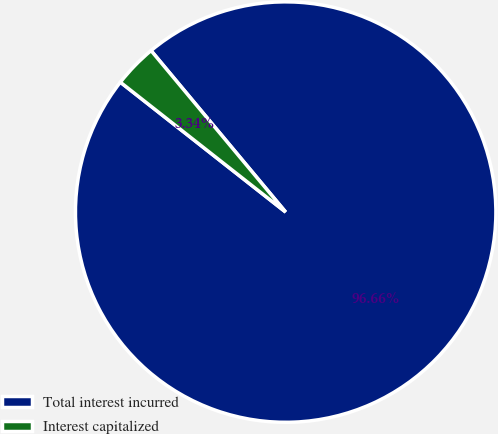<chart> <loc_0><loc_0><loc_500><loc_500><pie_chart><fcel>Total interest incurred<fcel>Interest capitalized<nl><fcel>96.66%<fcel>3.34%<nl></chart> 